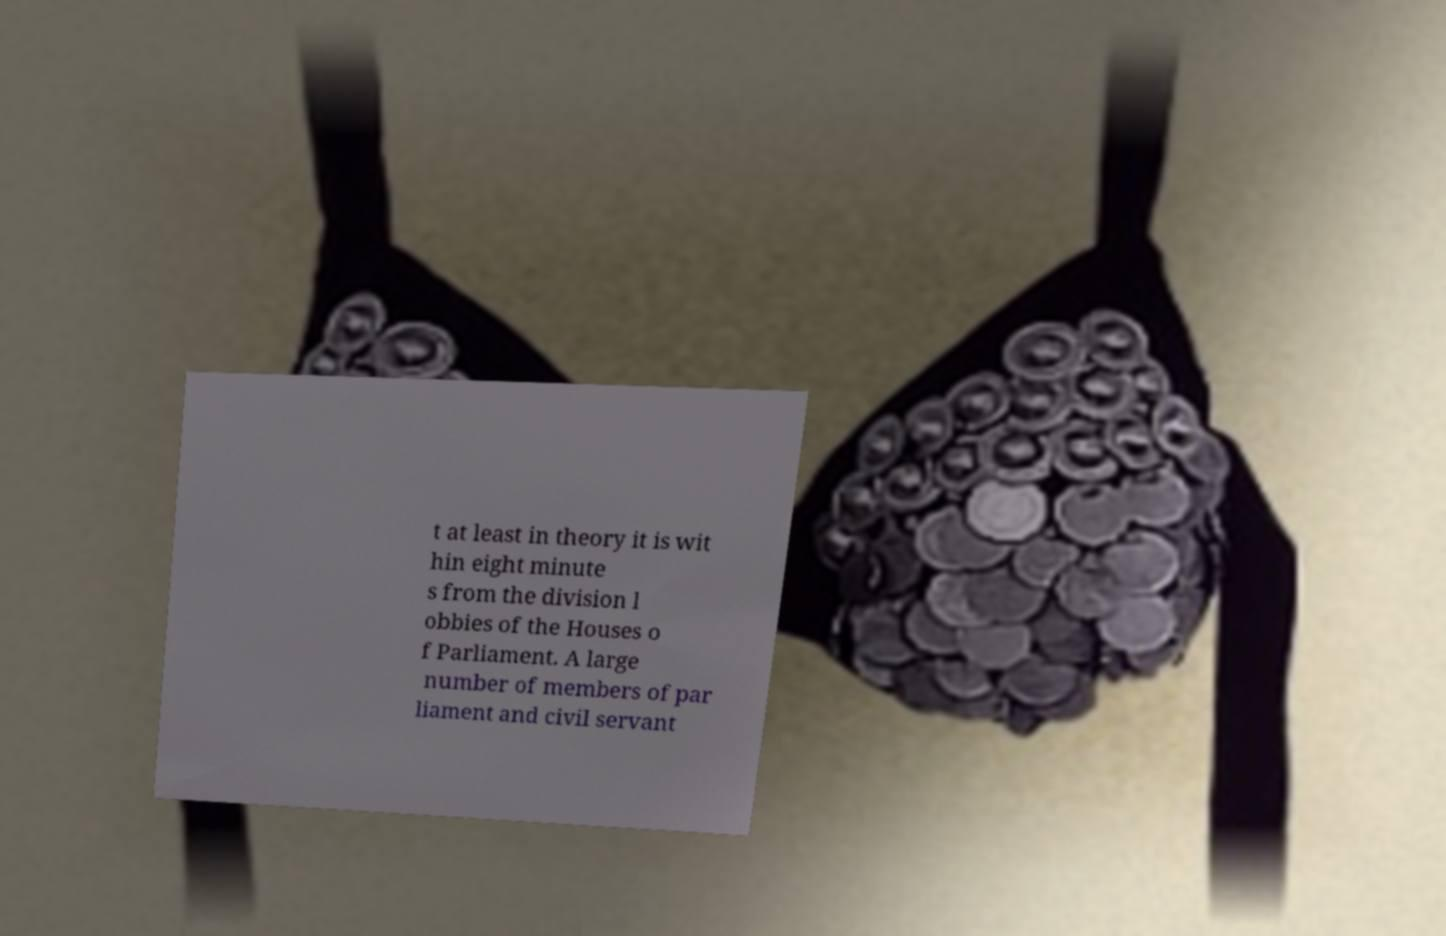Can you accurately transcribe the text from the provided image for me? t at least in theory it is wit hin eight minute s from the division l obbies of the Houses o f Parliament. A large number of members of par liament and civil servant 